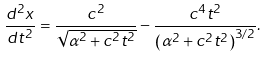<formula> <loc_0><loc_0><loc_500><loc_500>\frac { d ^ { 2 } x } { d t ^ { 2 } } = \frac { c ^ { 2 } } { \sqrt { \alpha ^ { 2 } + c ^ { 2 } t ^ { 2 } } } - \frac { c ^ { 4 } t ^ { 2 } } { \left ( \alpha ^ { 2 } + c ^ { 2 } t ^ { 2 } \right ) ^ { 3 / 2 } } .</formula> 